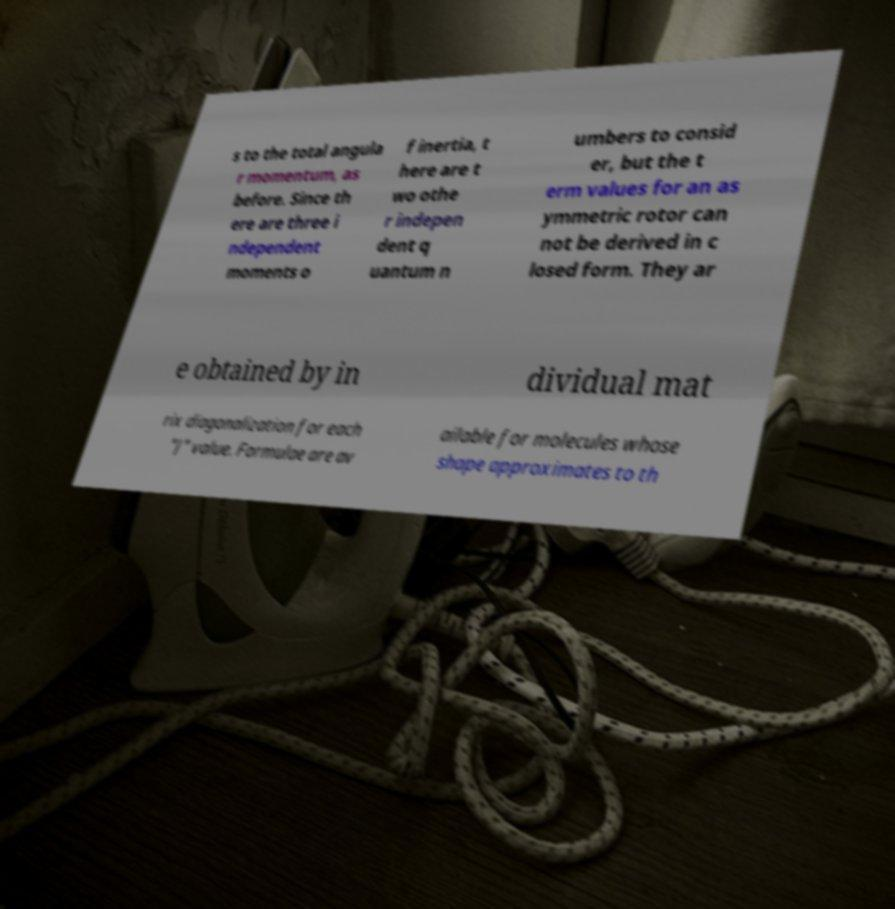I need the written content from this picture converted into text. Can you do that? s to the total angula r momentum, as before. Since th ere are three i ndependent moments o f inertia, t here are t wo othe r indepen dent q uantum n umbers to consid er, but the t erm values for an as ymmetric rotor can not be derived in c losed form. They ar e obtained by in dividual mat rix diagonalization for each "J" value. Formulae are av ailable for molecules whose shape approximates to th 